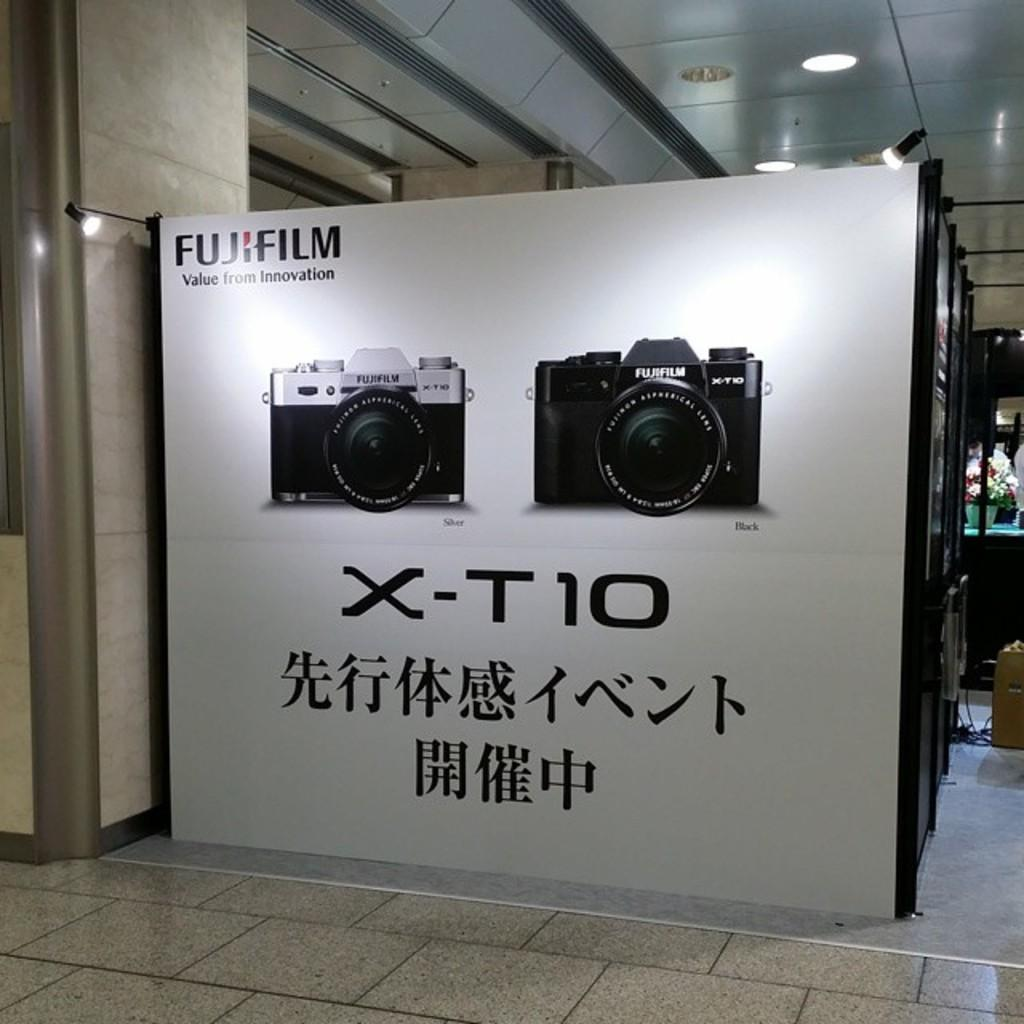<image>
Provide a brief description of the given image. Fujifilm cameras are on display on a picture 